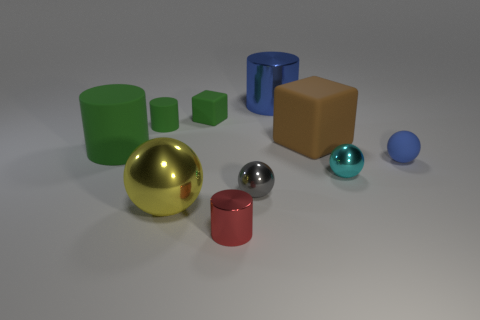What number of other things are the same color as the big rubber cylinder?
Keep it short and to the point. 2. Are there any purple cylinders?
Offer a terse response. No. Is there a tiny brown cylinder made of the same material as the tiny gray sphere?
Offer a very short reply. No. Are there more balls to the right of the big brown rubber object than large shiny things in front of the small metallic cylinder?
Give a very brief answer. Yes. Does the green cube have the same size as the gray shiny ball?
Provide a short and direct response. Yes. There is a metallic thing on the right side of the rubber block that is to the right of the tiny red metal object; what is its color?
Keep it short and to the point. Cyan. What color is the small matte cube?
Provide a succinct answer. Green. Is there a cylinder of the same color as the large block?
Make the answer very short. No. Do the shiny cylinder that is in front of the green matte block and the big rubber block have the same color?
Make the answer very short. No. What number of objects are balls in front of the matte sphere or cyan metal spheres?
Keep it short and to the point. 3. 